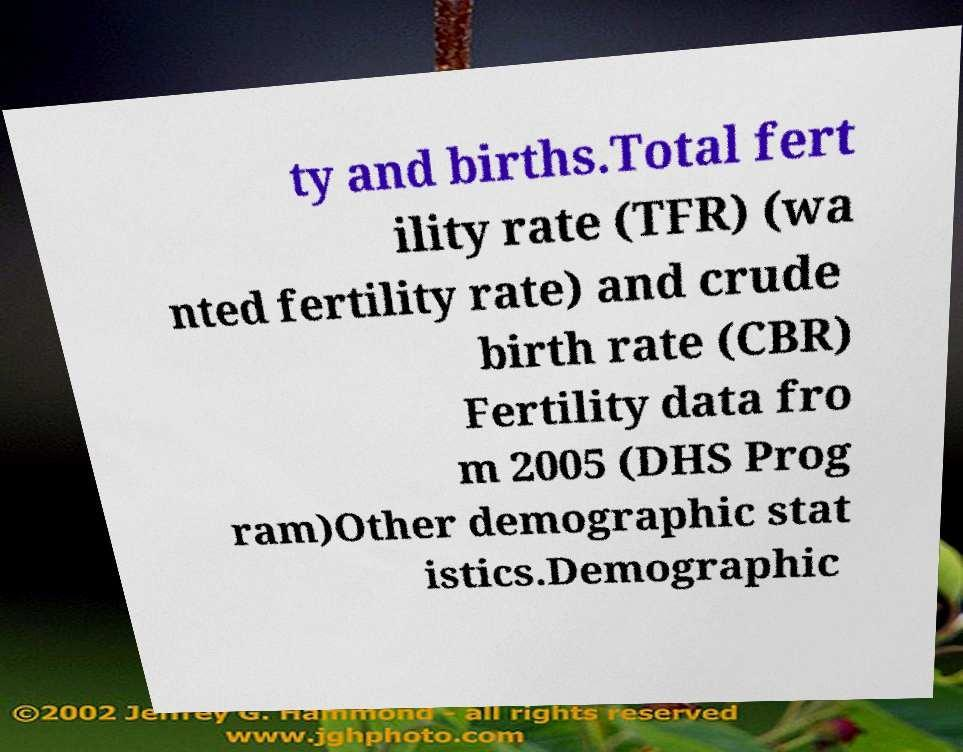Can you accurately transcribe the text from the provided image for me? ty and births.Total fert ility rate (TFR) (wa nted fertility rate) and crude birth rate (CBR) Fertility data fro m 2005 (DHS Prog ram)Other demographic stat istics.Demographic 